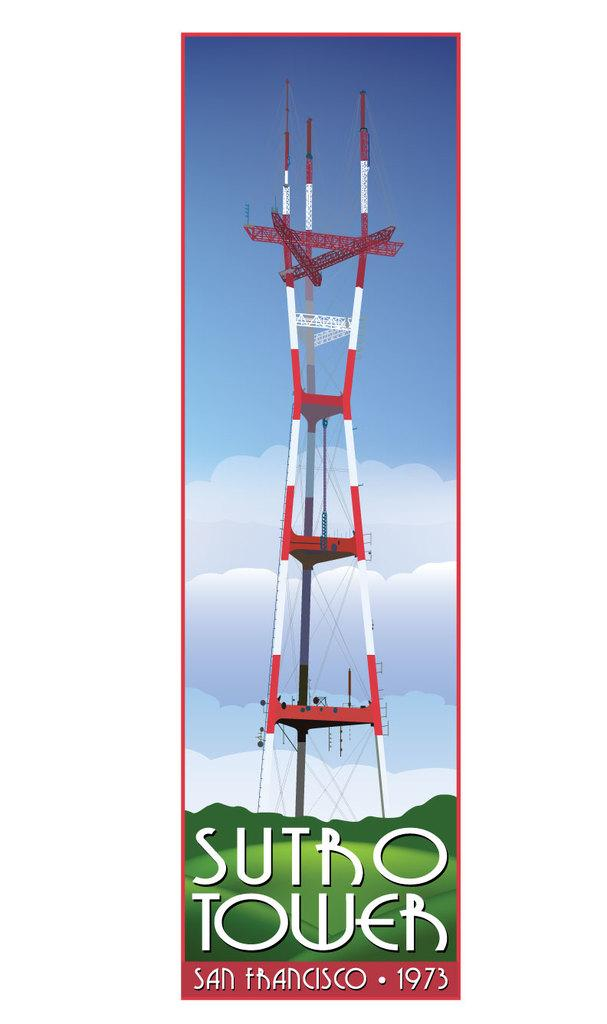<image>
Provide a brief description of the given image. poster showing a radio tower named sutro tower in san francisco in 1973 